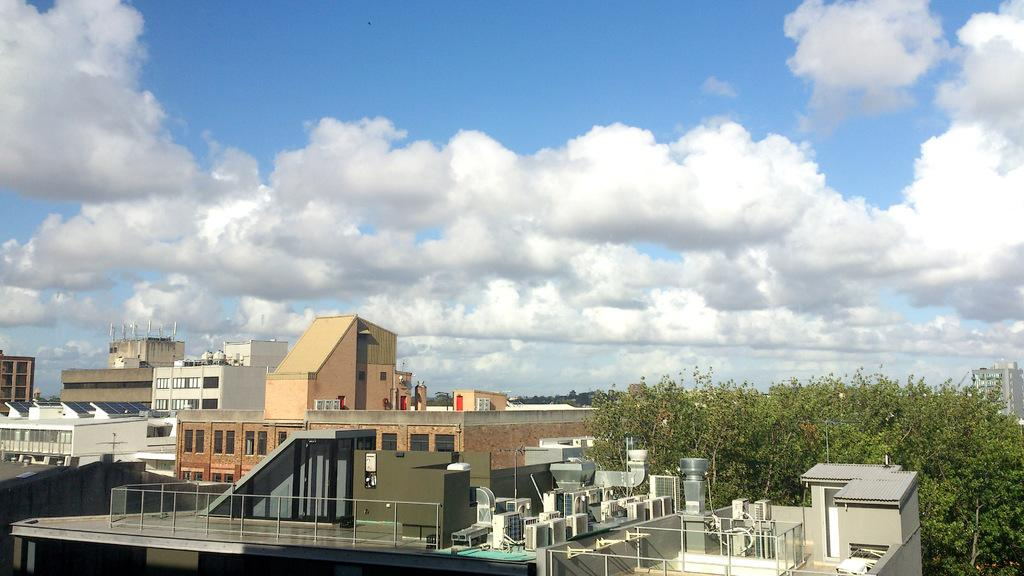What type of structures can be seen in the image? There are buildings in the image. What devices are present on the buildings? Air conditioners are present in the image. What type of vegetation is visible in the image? There are trees in the image. What type of energy-efficient technology is visible in the image? Solar panels are visible in the image. What part of the natural environment is visible in the image? The sky is visible in the image. What weather condition can be observed in the sky? Clouds are present in the sky. How many toys are scattered on the ground in the image? There are no toys present in the image. What type of door is visible on the building in the image? There is no door visible on the building in the image. 